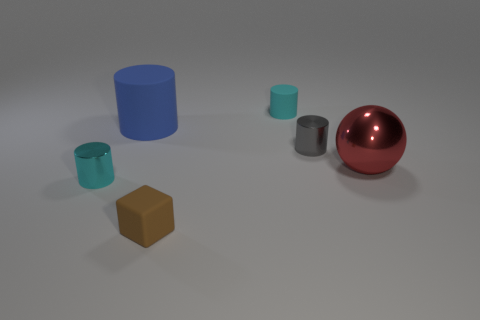Subtract all cyan matte cylinders. How many cylinders are left? 3 Subtract 2 cylinders. How many cylinders are left? 2 Add 2 tiny blue things. How many objects exist? 8 Subtract all blocks. How many objects are left? 5 Subtract all yellow balls. Subtract all blue cylinders. How many balls are left? 1 Subtract all cyan cubes. How many gray cylinders are left? 1 Subtract all tiny cyan cylinders. Subtract all cyan cylinders. How many objects are left? 2 Add 2 balls. How many balls are left? 3 Add 1 matte blocks. How many matte blocks exist? 2 Subtract all gray cylinders. How many cylinders are left? 3 